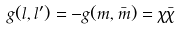Convert formula to latex. <formula><loc_0><loc_0><loc_500><loc_500>g ( l , l ^ { \prime } ) = - g ( m , \bar { m } ) = \chi \bar { \chi }</formula> 